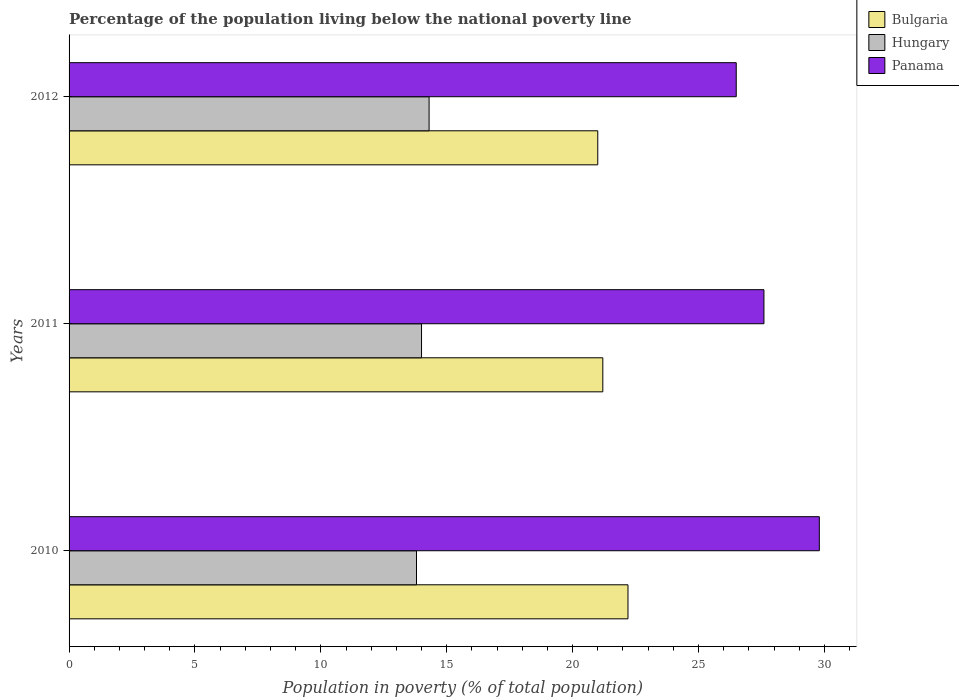How many different coloured bars are there?
Offer a terse response. 3. Are the number of bars per tick equal to the number of legend labels?
Ensure brevity in your answer.  Yes. Are the number of bars on each tick of the Y-axis equal?
Your answer should be very brief. Yes. How many bars are there on the 1st tick from the top?
Give a very brief answer. 3. How many bars are there on the 1st tick from the bottom?
Your answer should be very brief. 3. What is the label of the 1st group of bars from the top?
Offer a very short reply. 2012. What is the percentage of the population living below the national poverty line in Bulgaria in 2010?
Offer a terse response. 22.2. Across all years, what is the maximum percentage of the population living below the national poverty line in Hungary?
Offer a very short reply. 14.3. What is the total percentage of the population living below the national poverty line in Hungary in the graph?
Ensure brevity in your answer.  42.1. What is the difference between the percentage of the population living below the national poverty line in Panama in 2011 and that in 2012?
Ensure brevity in your answer.  1.1. What is the difference between the percentage of the population living below the national poverty line in Bulgaria in 2011 and the percentage of the population living below the national poverty line in Hungary in 2012?
Your response must be concise. 6.9. What is the average percentage of the population living below the national poverty line in Panama per year?
Your response must be concise. 27.97. In the year 2011, what is the difference between the percentage of the population living below the national poverty line in Hungary and percentage of the population living below the national poverty line in Panama?
Offer a terse response. -13.6. What is the ratio of the percentage of the population living below the national poverty line in Bulgaria in 2010 to that in 2011?
Your response must be concise. 1.05. Is the percentage of the population living below the national poverty line in Hungary in 2010 less than that in 2012?
Offer a very short reply. Yes. Is the difference between the percentage of the population living below the national poverty line in Hungary in 2010 and 2011 greater than the difference between the percentage of the population living below the national poverty line in Panama in 2010 and 2011?
Ensure brevity in your answer.  No. What is the difference between the highest and the second highest percentage of the population living below the national poverty line in Panama?
Give a very brief answer. 2.2. What is the difference between the highest and the lowest percentage of the population living below the national poverty line in Panama?
Keep it short and to the point. 3.3. What does the 3rd bar from the bottom in 2011 represents?
Your response must be concise. Panama. How many bars are there?
Give a very brief answer. 9. Are all the bars in the graph horizontal?
Ensure brevity in your answer.  Yes. How many years are there in the graph?
Your answer should be compact. 3. What is the difference between two consecutive major ticks on the X-axis?
Your answer should be compact. 5. Are the values on the major ticks of X-axis written in scientific E-notation?
Your answer should be compact. No. Does the graph contain any zero values?
Offer a very short reply. No. Does the graph contain grids?
Provide a succinct answer. No. Where does the legend appear in the graph?
Provide a succinct answer. Top right. What is the title of the graph?
Your answer should be very brief. Percentage of the population living below the national poverty line. Does "Mongolia" appear as one of the legend labels in the graph?
Your answer should be compact. No. What is the label or title of the X-axis?
Provide a short and direct response. Population in poverty (% of total population). What is the label or title of the Y-axis?
Provide a succinct answer. Years. What is the Population in poverty (% of total population) of Panama in 2010?
Provide a short and direct response. 29.8. What is the Population in poverty (% of total population) in Bulgaria in 2011?
Your answer should be very brief. 21.2. What is the Population in poverty (% of total population) in Panama in 2011?
Provide a succinct answer. 27.6. What is the Population in poverty (% of total population) in Bulgaria in 2012?
Offer a terse response. 21. What is the Population in poverty (% of total population) in Hungary in 2012?
Ensure brevity in your answer.  14.3. What is the Population in poverty (% of total population) of Panama in 2012?
Make the answer very short. 26.5. Across all years, what is the maximum Population in poverty (% of total population) of Bulgaria?
Your answer should be compact. 22.2. Across all years, what is the maximum Population in poverty (% of total population) of Hungary?
Your response must be concise. 14.3. Across all years, what is the maximum Population in poverty (% of total population) in Panama?
Offer a terse response. 29.8. Across all years, what is the minimum Population in poverty (% of total population) in Bulgaria?
Provide a short and direct response. 21. What is the total Population in poverty (% of total population) of Bulgaria in the graph?
Provide a short and direct response. 64.4. What is the total Population in poverty (% of total population) of Hungary in the graph?
Make the answer very short. 42.1. What is the total Population in poverty (% of total population) in Panama in the graph?
Keep it short and to the point. 83.9. What is the difference between the Population in poverty (% of total population) in Bulgaria in 2010 and that in 2011?
Ensure brevity in your answer.  1. What is the difference between the Population in poverty (% of total population) in Panama in 2010 and that in 2011?
Give a very brief answer. 2.2. What is the difference between the Population in poverty (% of total population) in Hungary in 2010 and that in 2012?
Your response must be concise. -0.5. What is the difference between the Population in poverty (% of total population) of Bulgaria in 2011 and that in 2012?
Provide a succinct answer. 0.2. What is the difference between the Population in poverty (% of total population) in Hungary in 2011 and that in 2012?
Your answer should be compact. -0.3. What is the difference between the Population in poverty (% of total population) in Bulgaria in 2010 and the Population in poverty (% of total population) in Panama in 2011?
Offer a very short reply. -5.4. What is the difference between the Population in poverty (% of total population) of Hungary in 2010 and the Population in poverty (% of total population) of Panama in 2011?
Offer a terse response. -13.8. What is the difference between the Population in poverty (% of total population) of Bulgaria in 2010 and the Population in poverty (% of total population) of Hungary in 2012?
Offer a terse response. 7.9. What is the difference between the Population in poverty (% of total population) of Hungary in 2010 and the Population in poverty (% of total population) of Panama in 2012?
Give a very brief answer. -12.7. What is the difference between the Population in poverty (% of total population) of Bulgaria in 2011 and the Population in poverty (% of total population) of Hungary in 2012?
Ensure brevity in your answer.  6.9. What is the difference between the Population in poverty (% of total population) of Bulgaria in 2011 and the Population in poverty (% of total population) of Panama in 2012?
Provide a short and direct response. -5.3. What is the average Population in poverty (% of total population) in Bulgaria per year?
Give a very brief answer. 21.47. What is the average Population in poverty (% of total population) in Hungary per year?
Ensure brevity in your answer.  14.03. What is the average Population in poverty (% of total population) in Panama per year?
Your answer should be very brief. 27.97. In the year 2010, what is the difference between the Population in poverty (% of total population) in Bulgaria and Population in poverty (% of total population) in Hungary?
Give a very brief answer. 8.4. In the year 2010, what is the difference between the Population in poverty (% of total population) in Hungary and Population in poverty (% of total population) in Panama?
Ensure brevity in your answer.  -16. In the year 2011, what is the difference between the Population in poverty (% of total population) in Bulgaria and Population in poverty (% of total population) in Hungary?
Offer a very short reply. 7.2. In the year 2012, what is the difference between the Population in poverty (% of total population) in Bulgaria and Population in poverty (% of total population) in Hungary?
Offer a very short reply. 6.7. In the year 2012, what is the difference between the Population in poverty (% of total population) of Bulgaria and Population in poverty (% of total population) of Panama?
Keep it short and to the point. -5.5. What is the ratio of the Population in poverty (% of total population) in Bulgaria in 2010 to that in 2011?
Your answer should be very brief. 1.05. What is the ratio of the Population in poverty (% of total population) in Hungary in 2010 to that in 2011?
Keep it short and to the point. 0.99. What is the ratio of the Population in poverty (% of total population) in Panama in 2010 to that in 2011?
Keep it short and to the point. 1.08. What is the ratio of the Population in poverty (% of total population) in Bulgaria in 2010 to that in 2012?
Make the answer very short. 1.06. What is the ratio of the Population in poverty (% of total population) of Hungary in 2010 to that in 2012?
Give a very brief answer. 0.96. What is the ratio of the Population in poverty (% of total population) of Panama in 2010 to that in 2012?
Provide a succinct answer. 1.12. What is the ratio of the Population in poverty (% of total population) of Bulgaria in 2011 to that in 2012?
Your answer should be compact. 1.01. What is the ratio of the Population in poverty (% of total population) of Hungary in 2011 to that in 2012?
Offer a very short reply. 0.98. What is the ratio of the Population in poverty (% of total population) in Panama in 2011 to that in 2012?
Ensure brevity in your answer.  1.04. What is the difference between the highest and the second highest Population in poverty (% of total population) in Bulgaria?
Your response must be concise. 1. What is the difference between the highest and the second highest Population in poverty (% of total population) of Hungary?
Your answer should be very brief. 0.3. What is the difference between the highest and the second highest Population in poverty (% of total population) in Panama?
Provide a succinct answer. 2.2. What is the difference between the highest and the lowest Population in poverty (% of total population) in Hungary?
Keep it short and to the point. 0.5. 